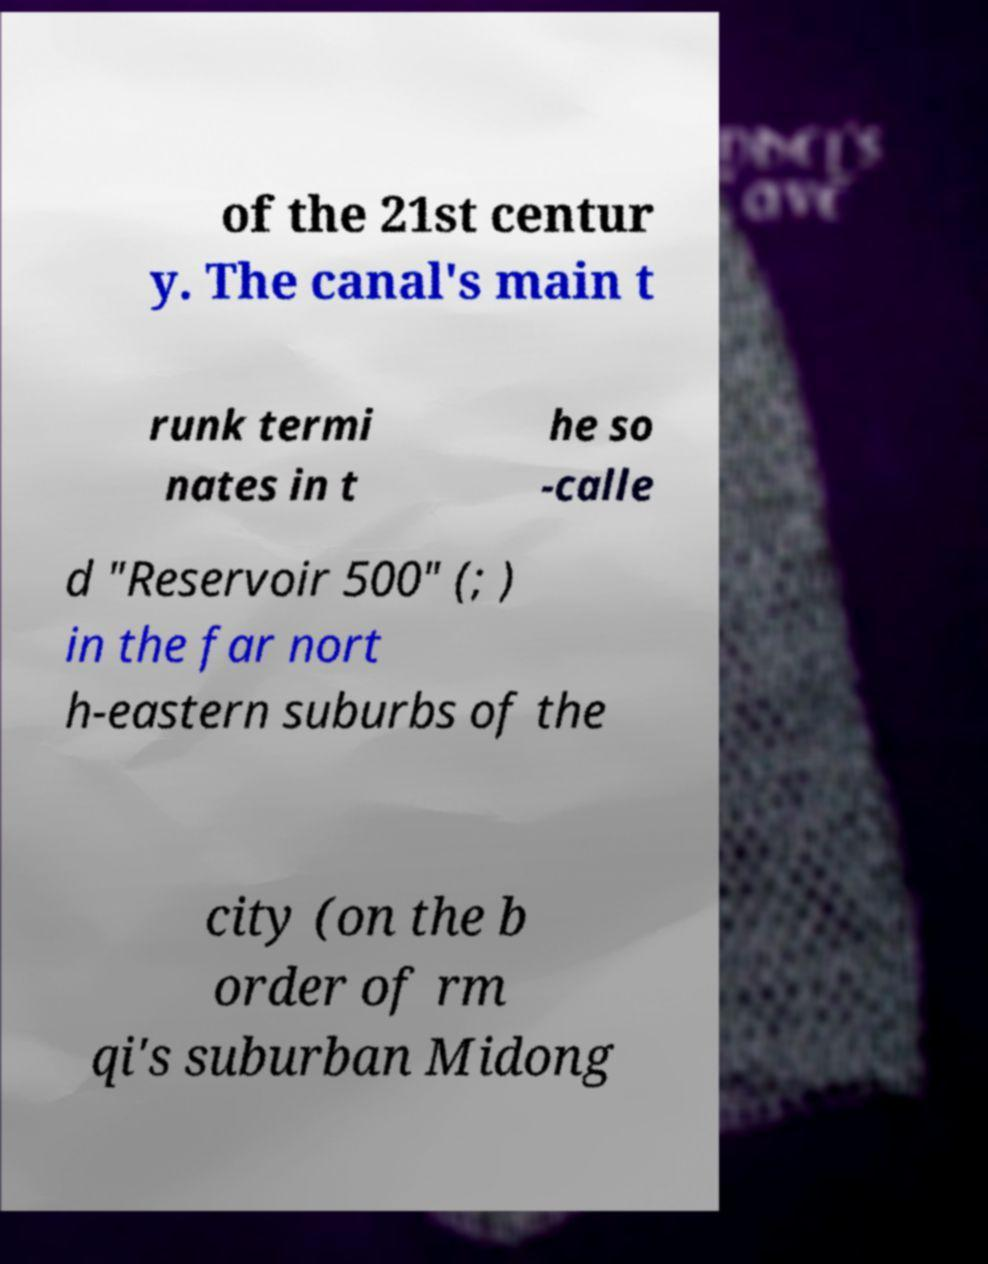Could you extract and type out the text from this image? of the 21st centur y. The canal's main t runk termi nates in t he so -calle d "Reservoir 500" (; ) in the far nort h-eastern suburbs of the city (on the b order of rm qi's suburban Midong 